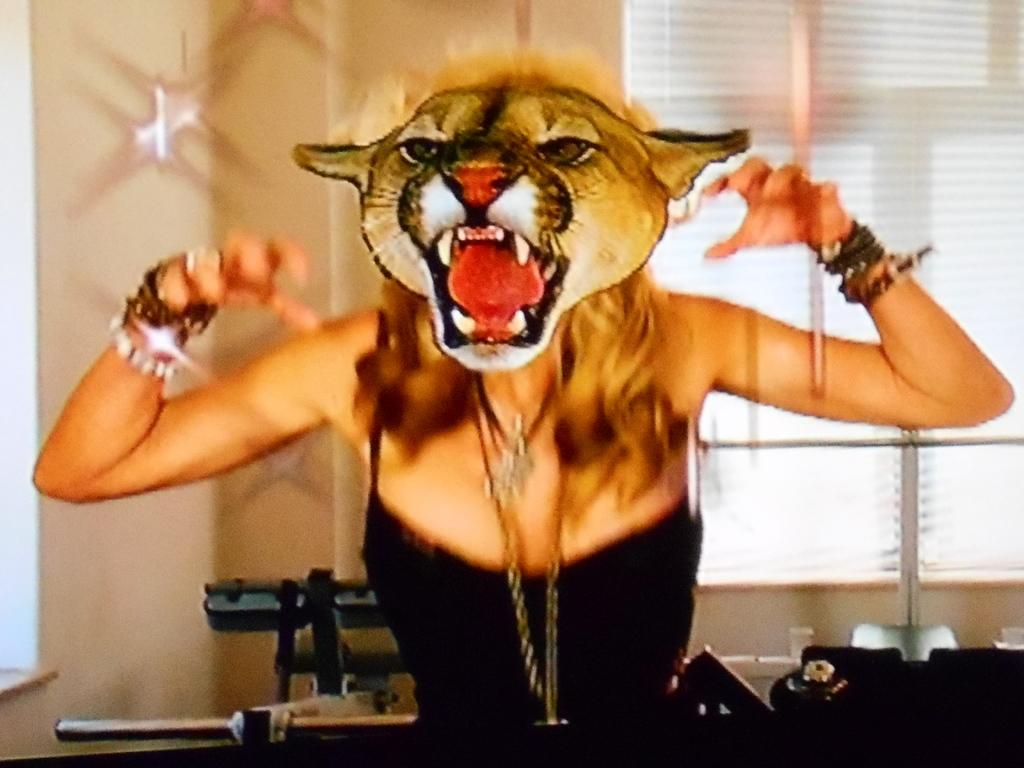Who is the main subject in the image? There is a woman in the center of the image. What is the woman wearing on her face? The woman is wearing a mask. What can be seen in the background of the image? There is a wall and blinds in the background of the image. What is located at the bottom of the image? There is a table at the bottom of the image. What type of error can be seen on the woman's face in the image? There is no error visible on the woman's face in the image; she is wearing a mask. How does the acoustics of the room affect the woman's voice in the image? The image does not provide any information about the acoustics of the room or the woman's voice. 